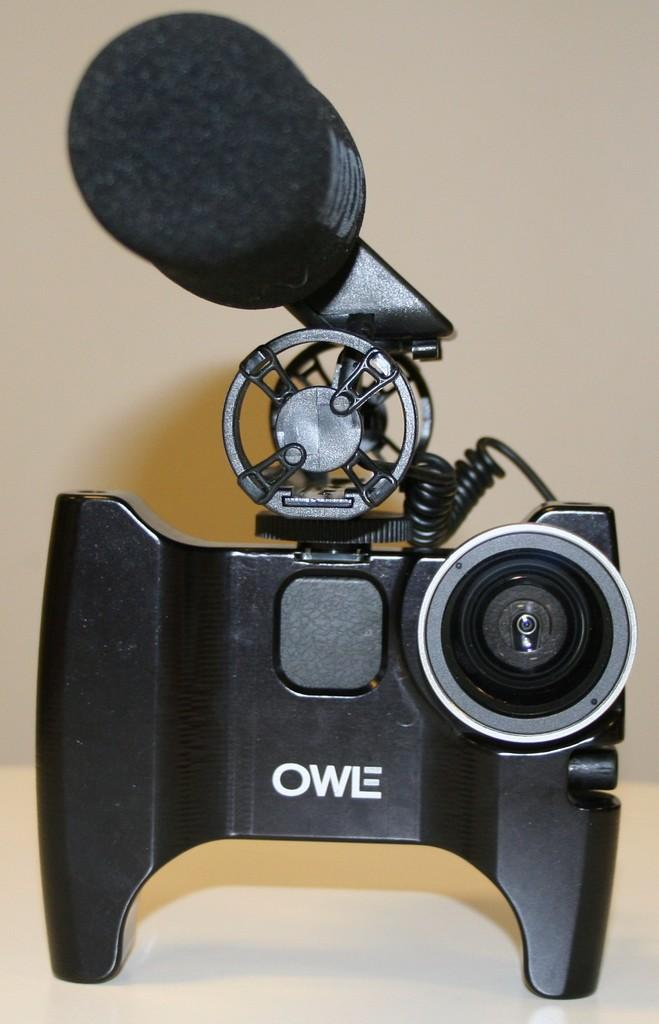What object is the main subject of the image? There is a camera in the image. Where is the camera located? The camera is on a surface. What can be seen in the background of the image? There is a wall visible in the background of the image. What type of cave can be seen in the background of the image? There is no cave present in the image; it features a wall in the background. What educational institution is associated with the camera in the image? There is no information about any educational institution in the image; it only shows a camera on a surface with a wall in the background. 